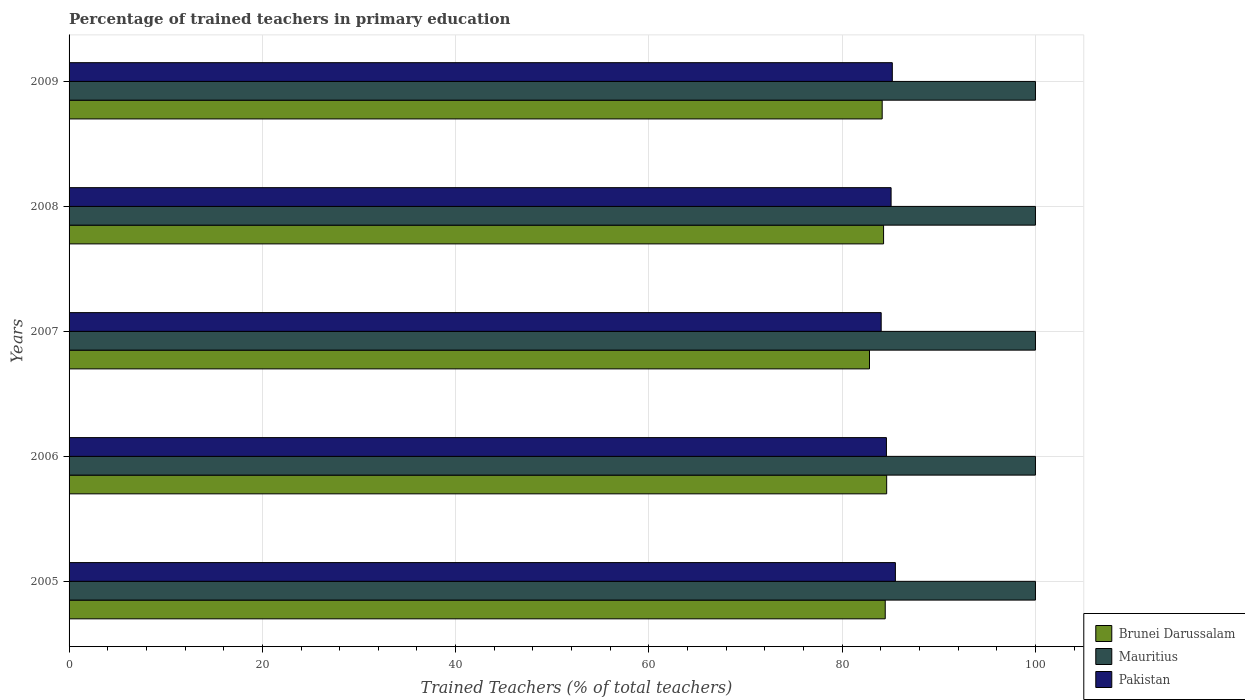How many bars are there on the 3rd tick from the top?
Provide a succinct answer. 3. How many bars are there on the 1st tick from the bottom?
Your answer should be compact. 3. What is the percentage of trained teachers in Brunei Darussalam in 2009?
Make the answer very short. 84.14. Across all years, what is the maximum percentage of trained teachers in Brunei Darussalam?
Offer a very short reply. 84.6. Across all years, what is the minimum percentage of trained teachers in Pakistan?
Your answer should be compact. 84.04. In which year was the percentage of trained teachers in Pakistan minimum?
Offer a very short reply. 2007. What is the difference between the percentage of trained teachers in Pakistan in 2005 and that in 2006?
Your answer should be compact. 0.93. What is the difference between the percentage of trained teachers in Pakistan in 2006 and the percentage of trained teachers in Mauritius in 2007?
Make the answer very short. -15.42. What is the average percentage of trained teachers in Pakistan per year?
Your answer should be very brief. 84.87. In the year 2009, what is the difference between the percentage of trained teachers in Pakistan and percentage of trained teachers in Brunei Darussalam?
Give a very brief answer. 1.05. What is the ratio of the percentage of trained teachers in Pakistan in 2005 to that in 2008?
Offer a very short reply. 1.01. Is the percentage of trained teachers in Mauritius in 2005 less than that in 2006?
Give a very brief answer. No. Is the difference between the percentage of trained teachers in Pakistan in 2007 and 2009 greater than the difference between the percentage of trained teachers in Brunei Darussalam in 2007 and 2009?
Provide a short and direct response. Yes. What is the difference between the highest and the second highest percentage of trained teachers in Brunei Darussalam?
Your answer should be very brief. 0.15. What is the difference between the highest and the lowest percentage of trained teachers in Mauritius?
Your answer should be very brief. 0. In how many years, is the percentage of trained teachers in Pakistan greater than the average percentage of trained teachers in Pakistan taken over all years?
Offer a very short reply. 3. Is the sum of the percentage of trained teachers in Pakistan in 2006 and 2008 greater than the maximum percentage of trained teachers in Mauritius across all years?
Give a very brief answer. Yes. What does the 2nd bar from the top in 2008 represents?
Your response must be concise. Mauritius. What does the 2nd bar from the bottom in 2009 represents?
Ensure brevity in your answer.  Mauritius. Is it the case that in every year, the sum of the percentage of trained teachers in Pakistan and percentage of trained teachers in Mauritius is greater than the percentage of trained teachers in Brunei Darussalam?
Offer a terse response. Yes. How many bars are there?
Your response must be concise. 15. How many years are there in the graph?
Your response must be concise. 5. What is the difference between two consecutive major ticks on the X-axis?
Offer a very short reply. 20. Does the graph contain any zero values?
Give a very brief answer. No. Where does the legend appear in the graph?
Give a very brief answer. Bottom right. What is the title of the graph?
Make the answer very short. Percentage of trained teachers in primary education. Does "Other small states" appear as one of the legend labels in the graph?
Make the answer very short. No. What is the label or title of the X-axis?
Your response must be concise. Trained Teachers (% of total teachers). What is the Trained Teachers (% of total teachers) in Brunei Darussalam in 2005?
Give a very brief answer. 84.45. What is the Trained Teachers (% of total teachers) in Pakistan in 2005?
Provide a succinct answer. 85.51. What is the Trained Teachers (% of total teachers) of Brunei Darussalam in 2006?
Provide a short and direct response. 84.6. What is the Trained Teachers (% of total teachers) in Mauritius in 2006?
Provide a short and direct response. 100. What is the Trained Teachers (% of total teachers) of Pakistan in 2006?
Offer a very short reply. 84.58. What is the Trained Teachers (% of total teachers) of Brunei Darussalam in 2007?
Your answer should be compact. 82.83. What is the Trained Teachers (% of total teachers) of Pakistan in 2007?
Offer a very short reply. 84.04. What is the Trained Teachers (% of total teachers) of Brunei Darussalam in 2008?
Ensure brevity in your answer.  84.28. What is the Trained Teachers (% of total teachers) in Mauritius in 2008?
Ensure brevity in your answer.  100. What is the Trained Teachers (% of total teachers) of Pakistan in 2008?
Your response must be concise. 85.06. What is the Trained Teachers (% of total teachers) in Brunei Darussalam in 2009?
Make the answer very short. 84.14. What is the Trained Teachers (% of total teachers) in Pakistan in 2009?
Offer a terse response. 85.19. Across all years, what is the maximum Trained Teachers (% of total teachers) in Brunei Darussalam?
Your answer should be compact. 84.6. Across all years, what is the maximum Trained Teachers (% of total teachers) of Pakistan?
Keep it short and to the point. 85.51. Across all years, what is the minimum Trained Teachers (% of total teachers) of Brunei Darussalam?
Make the answer very short. 82.83. Across all years, what is the minimum Trained Teachers (% of total teachers) of Mauritius?
Make the answer very short. 100. Across all years, what is the minimum Trained Teachers (% of total teachers) in Pakistan?
Ensure brevity in your answer.  84.04. What is the total Trained Teachers (% of total teachers) in Brunei Darussalam in the graph?
Ensure brevity in your answer.  420.31. What is the total Trained Teachers (% of total teachers) in Mauritius in the graph?
Offer a very short reply. 500. What is the total Trained Teachers (% of total teachers) of Pakistan in the graph?
Your response must be concise. 424.37. What is the difference between the Trained Teachers (% of total teachers) in Brunei Darussalam in 2005 and that in 2006?
Give a very brief answer. -0.15. What is the difference between the Trained Teachers (% of total teachers) of Pakistan in 2005 and that in 2006?
Offer a terse response. 0.93. What is the difference between the Trained Teachers (% of total teachers) of Brunei Darussalam in 2005 and that in 2007?
Your answer should be compact. 1.63. What is the difference between the Trained Teachers (% of total teachers) in Pakistan in 2005 and that in 2007?
Keep it short and to the point. 1.47. What is the difference between the Trained Teachers (% of total teachers) of Brunei Darussalam in 2005 and that in 2008?
Provide a succinct answer. 0.17. What is the difference between the Trained Teachers (% of total teachers) in Mauritius in 2005 and that in 2008?
Make the answer very short. 0. What is the difference between the Trained Teachers (% of total teachers) in Pakistan in 2005 and that in 2008?
Keep it short and to the point. 0.44. What is the difference between the Trained Teachers (% of total teachers) in Brunei Darussalam in 2005 and that in 2009?
Give a very brief answer. 0.31. What is the difference between the Trained Teachers (% of total teachers) in Mauritius in 2005 and that in 2009?
Keep it short and to the point. 0. What is the difference between the Trained Teachers (% of total teachers) in Pakistan in 2005 and that in 2009?
Your response must be concise. 0.32. What is the difference between the Trained Teachers (% of total teachers) in Brunei Darussalam in 2006 and that in 2007?
Offer a terse response. 1.78. What is the difference between the Trained Teachers (% of total teachers) in Pakistan in 2006 and that in 2007?
Make the answer very short. 0.54. What is the difference between the Trained Teachers (% of total teachers) of Brunei Darussalam in 2006 and that in 2008?
Provide a succinct answer. 0.32. What is the difference between the Trained Teachers (% of total teachers) of Pakistan in 2006 and that in 2008?
Give a very brief answer. -0.48. What is the difference between the Trained Teachers (% of total teachers) of Brunei Darussalam in 2006 and that in 2009?
Your answer should be compact. 0.46. What is the difference between the Trained Teachers (% of total teachers) of Pakistan in 2006 and that in 2009?
Offer a very short reply. -0.61. What is the difference between the Trained Teachers (% of total teachers) of Brunei Darussalam in 2007 and that in 2008?
Ensure brevity in your answer.  -1.46. What is the difference between the Trained Teachers (% of total teachers) of Pakistan in 2007 and that in 2008?
Your response must be concise. -1.03. What is the difference between the Trained Teachers (% of total teachers) in Brunei Darussalam in 2007 and that in 2009?
Provide a short and direct response. -1.31. What is the difference between the Trained Teachers (% of total teachers) of Pakistan in 2007 and that in 2009?
Your response must be concise. -1.15. What is the difference between the Trained Teachers (% of total teachers) in Brunei Darussalam in 2008 and that in 2009?
Provide a succinct answer. 0.14. What is the difference between the Trained Teachers (% of total teachers) of Pakistan in 2008 and that in 2009?
Your response must be concise. -0.13. What is the difference between the Trained Teachers (% of total teachers) in Brunei Darussalam in 2005 and the Trained Teachers (% of total teachers) in Mauritius in 2006?
Your answer should be compact. -15.55. What is the difference between the Trained Teachers (% of total teachers) of Brunei Darussalam in 2005 and the Trained Teachers (% of total teachers) of Pakistan in 2006?
Make the answer very short. -0.13. What is the difference between the Trained Teachers (% of total teachers) of Mauritius in 2005 and the Trained Teachers (% of total teachers) of Pakistan in 2006?
Your response must be concise. 15.42. What is the difference between the Trained Teachers (% of total teachers) of Brunei Darussalam in 2005 and the Trained Teachers (% of total teachers) of Mauritius in 2007?
Your response must be concise. -15.55. What is the difference between the Trained Teachers (% of total teachers) in Brunei Darussalam in 2005 and the Trained Teachers (% of total teachers) in Pakistan in 2007?
Your answer should be compact. 0.42. What is the difference between the Trained Teachers (% of total teachers) in Mauritius in 2005 and the Trained Teachers (% of total teachers) in Pakistan in 2007?
Keep it short and to the point. 15.96. What is the difference between the Trained Teachers (% of total teachers) of Brunei Darussalam in 2005 and the Trained Teachers (% of total teachers) of Mauritius in 2008?
Your response must be concise. -15.55. What is the difference between the Trained Teachers (% of total teachers) in Brunei Darussalam in 2005 and the Trained Teachers (% of total teachers) in Pakistan in 2008?
Ensure brevity in your answer.  -0.61. What is the difference between the Trained Teachers (% of total teachers) in Mauritius in 2005 and the Trained Teachers (% of total teachers) in Pakistan in 2008?
Ensure brevity in your answer.  14.94. What is the difference between the Trained Teachers (% of total teachers) in Brunei Darussalam in 2005 and the Trained Teachers (% of total teachers) in Mauritius in 2009?
Offer a very short reply. -15.55. What is the difference between the Trained Teachers (% of total teachers) of Brunei Darussalam in 2005 and the Trained Teachers (% of total teachers) of Pakistan in 2009?
Ensure brevity in your answer.  -0.73. What is the difference between the Trained Teachers (% of total teachers) in Mauritius in 2005 and the Trained Teachers (% of total teachers) in Pakistan in 2009?
Your answer should be compact. 14.81. What is the difference between the Trained Teachers (% of total teachers) of Brunei Darussalam in 2006 and the Trained Teachers (% of total teachers) of Mauritius in 2007?
Keep it short and to the point. -15.4. What is the difference between the Trained Teachers (% of total teachers) in Brunei Darussalam in 2006 and the Trained Teachers (% of total teachers) in Pakistan in 2007?
Your answer should be very brief. 0.57. What is the difference between the Trained Teachers (% of total teachers) of Mauritius in 2006 and the Trained Teachers (% of total teachers) of Pakistan in 2007?
Your answer should be compact. 15.96. What is the difference between the Trained Teachers (% of total teachers) of Brunei Darussalam in 2006 and the Trained Teachers (% of total teachers) of Mauritius in 2008?
Keep it short and to the point. -15.4. What is the difference between the Trained Teachers (% of total teachers) in Brunei Darussalam in 2006 and the Trained Teachers (% of total teachers) in Pakistan in 2008?
Give a very brief answer. -0.46. What is the difference between the Trained Teachers (% of total teachers) of Mauritius in 2006 and the Trained Teachers (% of total teachers) of Pakistan in 2008?
Offer a very short reply. 14.94. What is the difference between the Trained Teachers (% of total teachers) in Brunei Darussalam in 2006 and the Trained Teachers (% of total teachers) in Mauritius in 2009?
Ensure brevity in your answer.  -15.4. What is the difference between the Trained Teachers (% of total teachers) in Brunei Darussalam in 2006 and the Trained Teachers (% of total teachers) in Pakistan in 2009?
Give a very brief answer. -0.58. What is the difference between the Trained Teachers (% of total teachers) in Mauritius in 2006 and the Trained Teachers (% of total teachers) in Pakistan in 2009?
Provide a succinct answer. 14.81. What is the difference between the Trained Teachers (% of total teachers) of Brunei Darussalam in 2007 and the Trained Teachers (% of total teachers) of Mauritius in 2008?
Your response must be concise. -17.17. What is the difference between the Trained Teachers (% of total teachers) of Brunei Darussalam in 2007 and the Trained Teachers (% of total teachers) of Pakistan in 2008?
Your response must be concise. -2.23. What is the difference between the Trained Teachers (% of total teachers) in Mauritius in 2007 and the Trained Teachers (% of total teachers) in Pakistan in 2008?
Your response must be concise. 14.94. What is the difference between the Trained Teachers (% of total teachers) of Brunei Darussalam in 2007 and the Trained Teachers (% of total teachers) of Mauritius in 2009?
Your answer should be compact. -17.17. What is the difference between the Trained Teachers (% of total teachers) of Brunei Darussalam in 2007 and the Trained Teachers (% of total teachers) of Pakistan in 2009?
Provide a succinct answer. -2.36. What is the difference between the Trained Teachers (% of total teachers) of Mauritius in 2007 and the Trained Teachers (% of total teachers) of Pakistan in 2009?
Keep it short and to the point. 14.81. What is the difference between the Trained Teachers (% of total teachers) in Brunei Darussalam in 2008 and the Trained Teachers (% of total teachers) in Mauritius in 2009?
Offer a terse response. -15.72. What is the difference between the Trained Teachers (% of total teachers) in Brunei Darussalam in 2008 and the Trained Teachers (% of total teachers) in Pakistan in 2009?
Keep it short and to the point. -0.9. What is the difference between the Trained Teachers (% of total teachers) in Mauritius in 2008 and the Trained Teachers (% of total teachers) in Pakistan in 2009?
Offer a terse response. 14.81. What is the average Trained Teachers (% of total teachers) of Brunei Darussalam per year?
Give a very brief answer. 84.06. What is the average Trained Teachers (% of total teachers) in Pakistan per year?
Your answer should be compact. 84.87. In the year 2005, what is the difference between the Trained Teachers (% of total teachers) of Brunei Darussalam and Trained Teachers (% of total teachers) of Mauritius?
Provide a short and direct response. -15.55. In the year 2005, what is the difference between the Trained Teachers (% of total teachers) in Brunei Darussalam and Trained Teachers (% of total teachers) in Pakistan?
Provide a succinct answer. -1.05. In the year 2005, what is the difference between the Trained Teachers (% of total teachers) of Mauritius and Trained Teachers (% of total teachers) of Pakistan?
Keep it short and to the point. 14.49. In the year 2006, what is the difference between the Trained Teachers (% of total teachers) in Brunei Darussalam and Trained Teachers (% of total teachers) in Mauritius?
Give a very brief answer. -15.4. In the year 2006, what is the difference between the Trained Teachers (% of total teachers) of Brunei Darussalam and Trained Teachers (% of total teachers) of Pakistan?
Make the answer very short. 0.03. In the year 2006, what is the difference between the Trained Teachers (% of total teachers) of Mauritius and Trained Teachers (% of total teachers) of Pakistan?
Make the answer very short. 15.42. In the year 2007, what is the difference between the Trained Teachers (% of total teachers) of Brunei Darussalam and Trained Teachers (% of total teachers) of Mauritius?
Your answer should be compact. -17.17. In the year 2007, what is the difference between the Trained Teachers (% of total teachers) of Brunei Darussalam and Trained Teachers (% of total teachers) of Pakistan?
Make the answer very short. -1.21. In the year 2007, what is the difference between the Trained Teachers (% of total teachers) of Mauritius and Trained Teachers (% of total teachers) of Pakistan?
Provide a succinct answer. 15.96. In the year 2008, what is the difference between the Trained Teachers (% of total teachers) in Brunei Darussalam and Trained Teachers (% of total teachers) in Mauritius?
Make the answer very short. -15.72. In the year 2008, what is the difference between the Trained Teachers (% of total teachers) of Brunei Darussalam and Trained Teachers (% of total teachers) of Pakistan?
Provide a succinct answer. -0.78. In the year 2008, what is the difference between the Trained Teachers (% of total teachers) of Mauritius and Trained Teachers (% of total teachers) of Pakistan?
Give a very brief answer. 14.94. In the year 2009, what is the difference between the Trained Teachers (% of total teachers) of Brunei Darussalam and Trained Teachers (% of total teachers) of Mauritius?
Offer a terse response. -15.86. In the year 2009, what is the difference between the Trained Teachers (% of total teachers) in Brunei Darussalam and Trained Teachers (% of total teachers) in Pakistan?
Keep it short and to the point. -1.05. In the year 2009, what is the difference between the Trained Teachers (% of total teachers) of Mauritius and Trained Teachers (% of total teachers) of Pakistan?
Offer a terse response. 14.81. What is the ratio of the Trained Teachers (% of total teachers) in Brunei Darussalam in 2005 to that in 2006?
Make the answer very short. 1. What is the ratio of the Trained Teachers (% of total teachers) in Mauritius in 2005 to that in 2006?
Give a very brief answer. 1. What is the ratio of the Trained Teachers (% of total teachers) in Pakistan in 2005 to that in 2006?
Ensure brevity in your answer.  1.01. What is the ratio of the Trained Teachers (% of total teachers) of Brunei Darussalam in 2005 to that in 2007?
Ensure brevity in your answer.  1.02. What is the ratio of the Trained Teachers (% of total teachers) in Pakistan in 2005 to that in 2007?
Provide a short and direct response. 1.02. What is the ratio of the Trained Teachers (% of total teachers) of Brunei Darussalam in 2005 to that in 2008?
Ensure brevity in your answer.  1. What is the ratio of the Trained Teachers (% of total teachers) in Mauritius in 2005 to that in 2008?
Your response must be concise. 1. What is the ratio of the Trained Teachers (% of total teachers) of Pakistan in 2005 to that in 2008?
Make the answer very short. 1.01. What is the ratio of the Trained Teachers (% of total teachers) of Brunei Darussalam in 2005 to that in 2009?
Offer a very short reply. 1. What is the ratio of the Trained Teachers (% of total teachers) of Mauritius in 2005 to that in 2009?
Ensure brevity in your answer.  1. What is the ratio of the Trained Teachers (% of total teachers) in Pakistan in 2005 to that in 2009?
Your answer should be compact. 1. What is the ratio of the Trained Teachers (% of total teachers) in Brunei Darussalam in 2006 to that in 2007?
Provide a succinct answer. 1.02. What is the ratio of the Trained Teachers (% of total teachers) of Mauritius in 2006 to that in 2007?
Your answer should be very brief. 1. What is the ratio of the Trained Teachers (% of total teachers) in Pakistan in 2006 to that in 2007?
Ensure brevity in your answer.  1.01. What is the ratio of the Trained Teachers (% of total teachers) in Pakistan in 2006 to that in 2008?
Provide a succinct answer. 0.99. What is the ratio of the Trained Teachers (% of total teachers) in Brunei Darussalam in 2006 to that in 2009?
Provide a short and direct response. 1.01. What is the ratio of the Trained Teachers (% of total teachers) of Mauritius in 2006 to that in 2009?
Make the answer very short. 1. What is the ratio of the Trained Teachers (% of total teachers) in Brunei Darussalam in 2007 to that in 2008?
Your answer should be very brief. 0.98. What is the ratio of the Trained Teachers (% of total teachers) of Mauritius in 2007 to that in 2008?
Give a very brief answer. 1. What is the ratio of the Trained Teachers (% of total teachers) in Pakistan in 2007 to that in 2008?
Make the answer very short. 0.99. What is the ratio of the Trained Teachers (% of total teachers) in Brunei Darussalam in 2007 to that in 2009?
Your response must be concise. 0.98. What is the ratio of the Trained Teachers (% of total teachers) of Mauritius in 2007 to that in 2009?
Your answer should be very brief. 1. What is the ratio of the Trained Teachers (% of total teachers) in Pakistan in 2007 to that in 2009?
Give a very brief answer. 0.99. What is the ratio of the Trained Teachers (% of total teachers) in Brunei Darussalam in 2008 to that in 2009?
Provide a succinct answer. 1. What is the ratio of the Trained Teachers (% of total teachers) in Pakistan in 2008 to that in 2009?
Your response must be concise. 1. What is the difference between the highest and the second highest Trained Teachers (% of total teachers) of Brunei Darussalam?
Offer a terse response. 0.15. What is the difference between the highest and the second highest Trained Teachers (% of total teachers) in Mauritius?
Your answer should be very brief. 0. What is the difference between the highest and the second highest Trained Teachers (% of total teachers) of Pakistan?
Offer a terse response. 0.32. What is the difference between the highest and the lowest Trained Teachers (% of total teachers) in Brunei Darussalam?
Keep it short and to the point. 1.78. What is the difference between the highest and the lowest Trained Teachers (% of total teachers) in Mauritius?
Ensure brevity in your answer.  0. What is the difference between the highest and the lowest Trained Teachers (% of total teachers) of Pakistan?
Your answer should be compact. 1.47. 